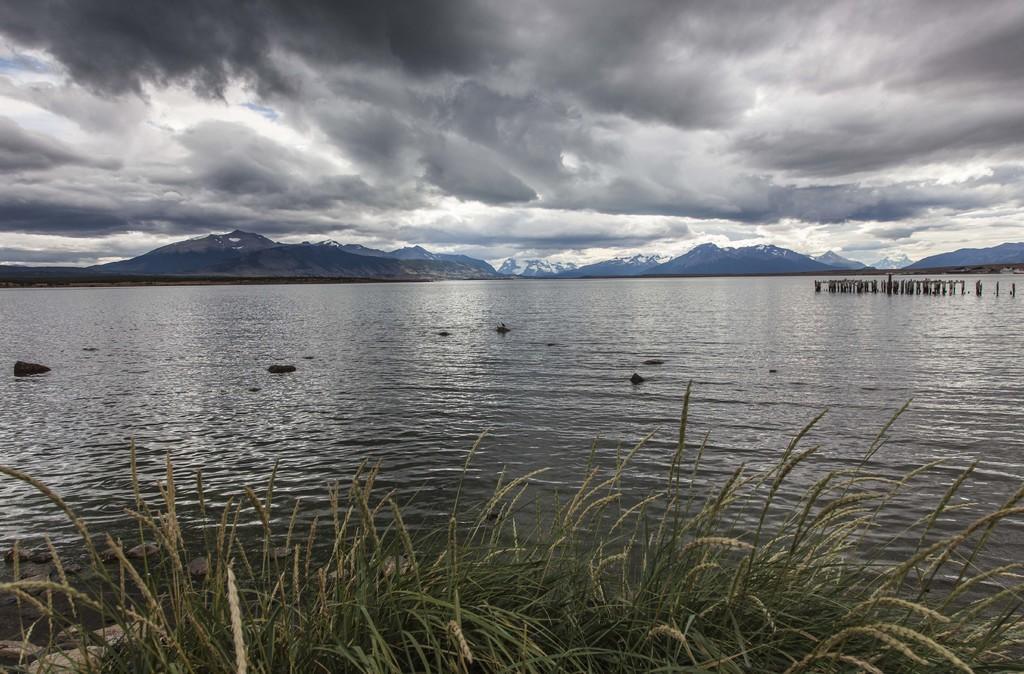Could you give a brief overview of what you see in this image? In this image, we can see mountains. At the top, there are clouds in the sky and at the bottom, there are plants and there is water and some poles. 